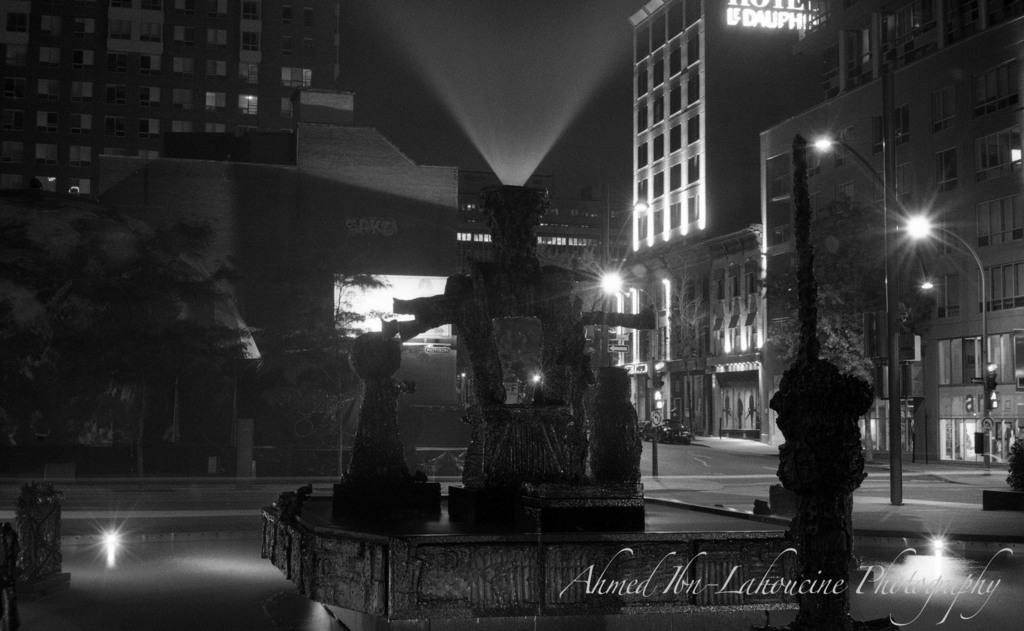What type of structures can be seen in the image? There are buildings in the image. What can be seen through the window in the image? The image does not show a window with a view, as it is black and white. What is the pole in the image used for? The purpose of the pole in the image is not specified, but it could be a utility pole or a traffic pole. What type of illumination is present in the image? There are lights in the image, which could be streetlights or building lights. What type of traffic control device is present in the image? There is a traffic signal in the image. Where is the church located in the image? There is no church present in the image. How many sheep can be seen grazing in the image? There are no sheep present in the image. What type of animal is the zebra in the image? There is no zebra present in the image. 